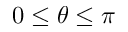<formula> <loc_0><loc_0><loc_500><loc_500>0 \leq \theta \leq \pi</formula> 